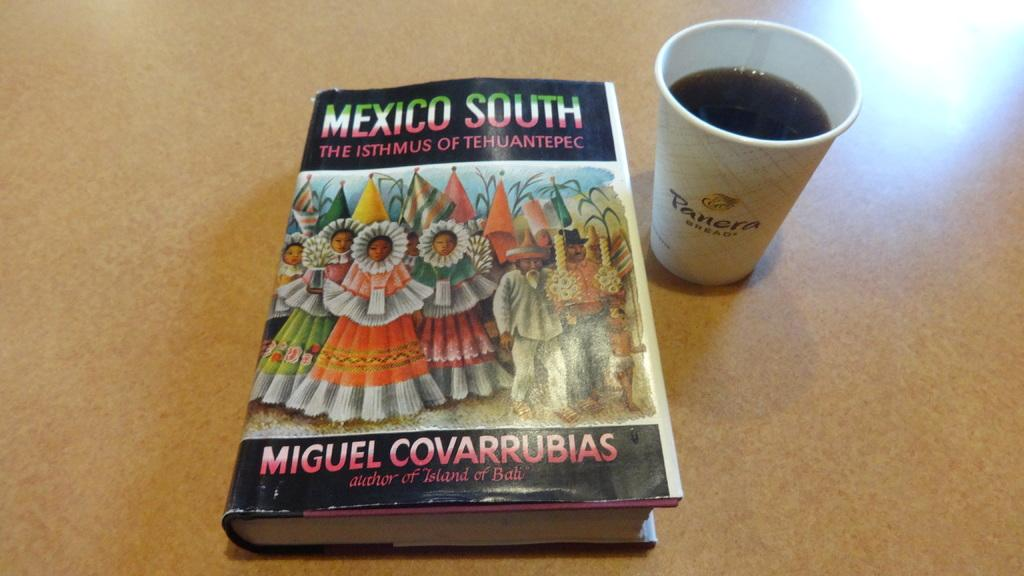<image>
Offer a succinct explanation of the picture presented. Next to a book about Mexico is a cup of coffee from Panera. . 